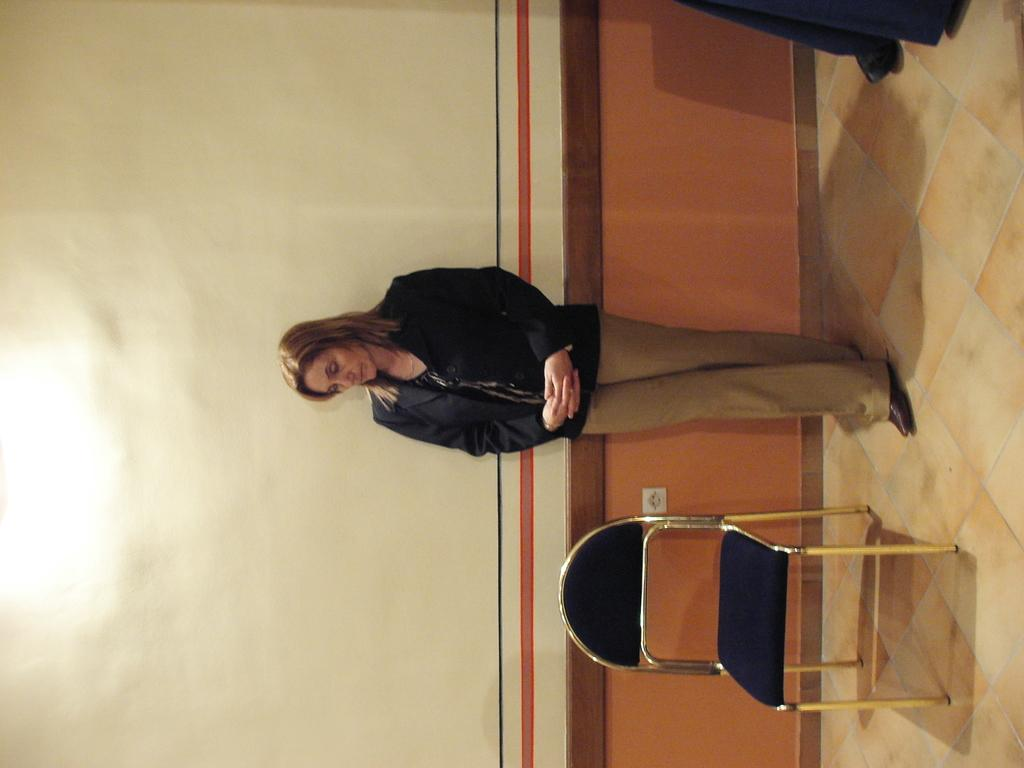Who is the main subject in the image? There is a lady in the image. What is the lady doing in the image? The lady is standing on the floor. What object is located beside the lady? There is a chair beside the lady. What can be seen in the background of the image? There is a wall in the background of the image. What type of fiction is the lady reading in the image? There is no book or any indication of reading in the image, so it cannot be determined what type of fiction the lady might be reading. 